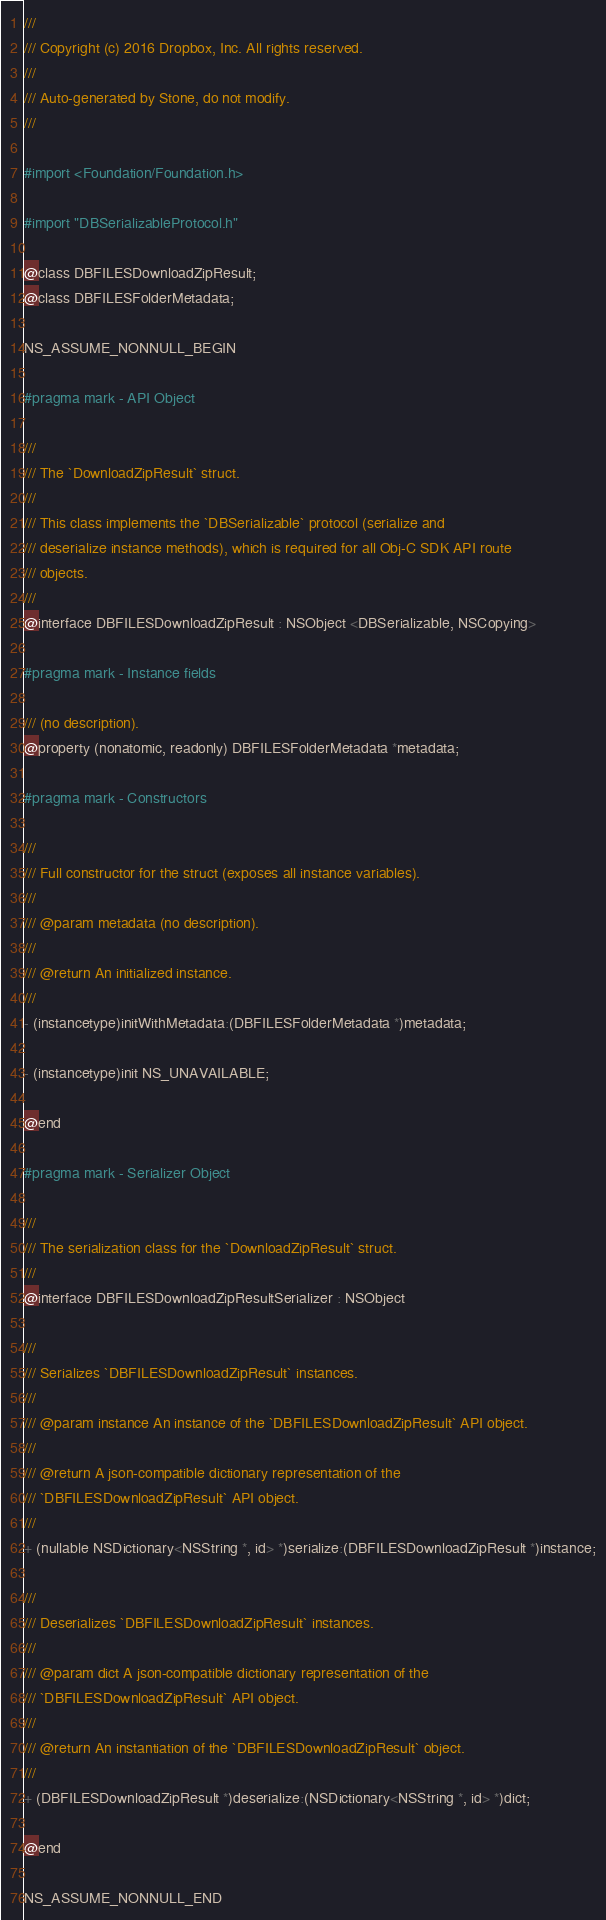Convert code to text. <code><loc_0><loc_0><loc_500><loc_500><_C_>///
/// Copyright (c) 2016 Dropbox, Inc. All rights reserved.
///
/// Auto-generated by Stone, do not modify.
///

#import <Foundation/Foundation.h>

#import "DBSerializableProtocol.h"

@class DBFILESDownloadZipResult;
@class DBFILESFolderMetadata;

NS_ASSUME_NONNULL_BEGIN

#pragma mark - API Object

///
/// The `DownloadZipResult` struct.
///
/// This class implements the `DBSerializable` protocol (serialize and
/// deserialize instance methods), which is required for all Obj-C SDK API route
/// objects.
///
@interface DBFILESDownloadZipResult : NSObject <DBSerializable, NSCopying>

#pragma mark - Instance fields

/// (no description).
@property (nonatomic, readonly) DBFILESFolderMetadata *metadata;

#pragma mark - Constructors

///
/// Full constructor for the struct (exposes all instance variables).
///
/// @param metadata (no description).
///
/// @return An initialized instance.
///
- (instancetype)initWithMetadata:(DBFILESFolderMetadata *)metadata;

- (instancetype)init NS_UNAVAILABLE;

@end

#pragma mark - Serializer Object

///
/// The serialization class for the `DownloadZipResult` struct.
///
@interface DBFILESDownloadZipResultSerializer : NSObject

///
/// Serializes `DBFILESDownloadZipResult` instances.
///
/// @param instance An instance of the `DBFILESDownloadZipResult` API object.
///
/// @return A json-compatible dictionary representation of the
/// `DBFILESDownloadZipResult` API object.
///
+ (nullable NSDictionary<NSString *, id> *)serialize:(DBFILESDownloadZipResult *)instance;

///
/// Deserializes `DBFILESDownloadZipResult` instances.
///
/// @param dict A json-compatible dictionary representation of the
/// `DBFILESDownloadZipResult` API object.
///
/// @return An instantiation of the `DBFILESDownloadZipResult` object.
///
+ (DBFILESDownloadZipResult *)deserialize:(NSDictionary<NSString *, id> *)dict;

@end

NS_ASSUME_NONNULL_END
</code> 